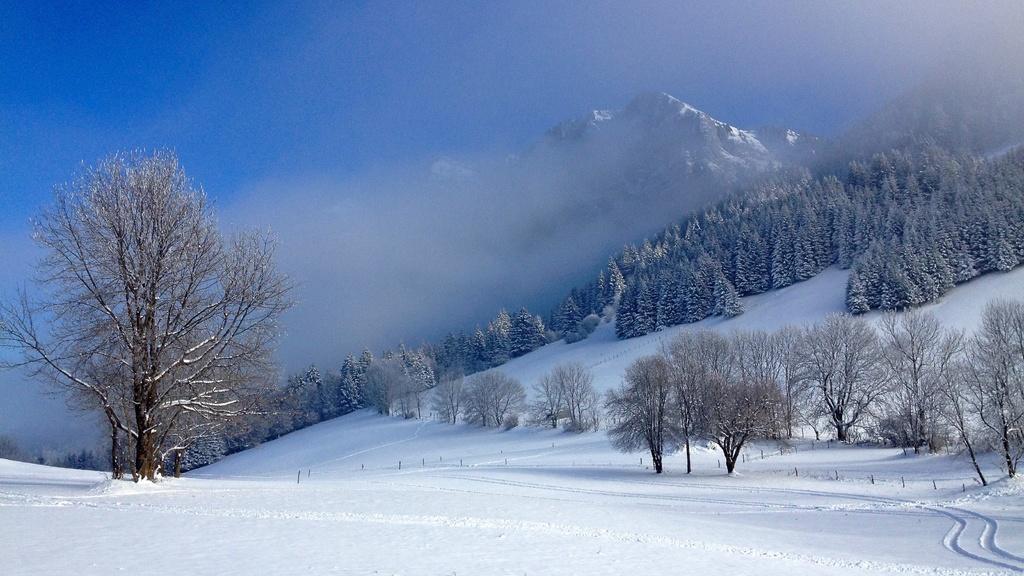How would you summarize this image in a sentence or two? In this picture we can see snow, trees, fog and hill. In the background of the image we can see the sky in blue color. 